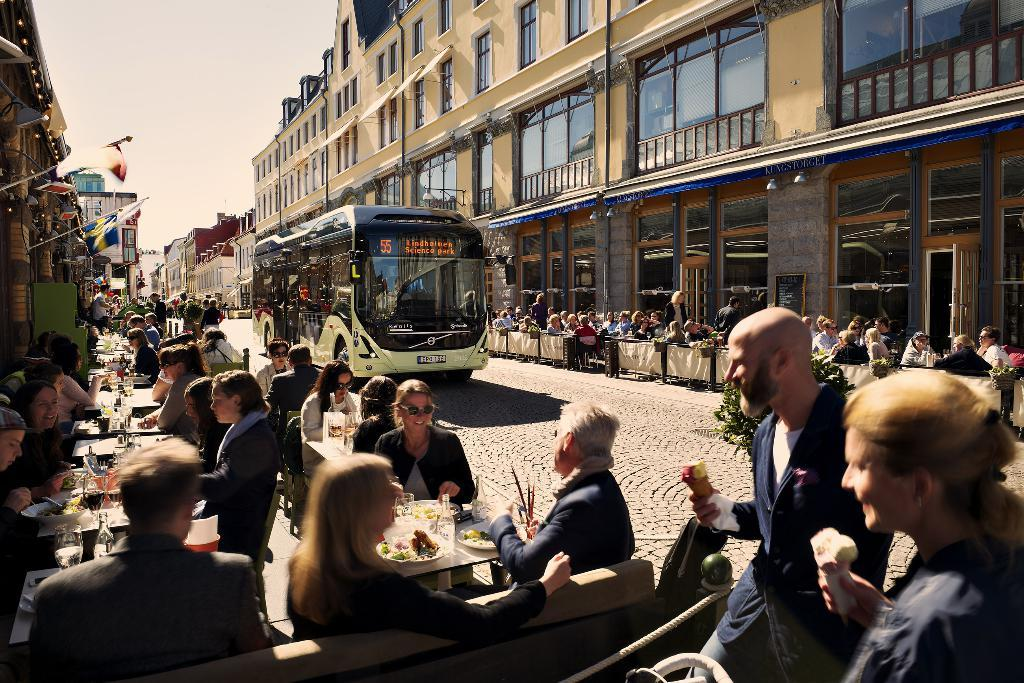How many people are in the image? There is a group of people in the image. What type of vehicle is present in the image? There is a bus in the image. What decorative or symbolic items can be seen in the image? There are flags in the image. What type of structures are visible in the image? There are buildings in the image. What part of the natural environment is visible in the image? The sky is visible in the image. What type of furniture is present in the image? There are chairs and tables in the image. What items can be seen on the tables? There are bottles, glasses, and dishes on the tables in the image. What type of crime is being committed in the image? There is no indication of any crime being committed in the image. How does the rabbit interact with the people in the image? There is no rabbit present in the image. 